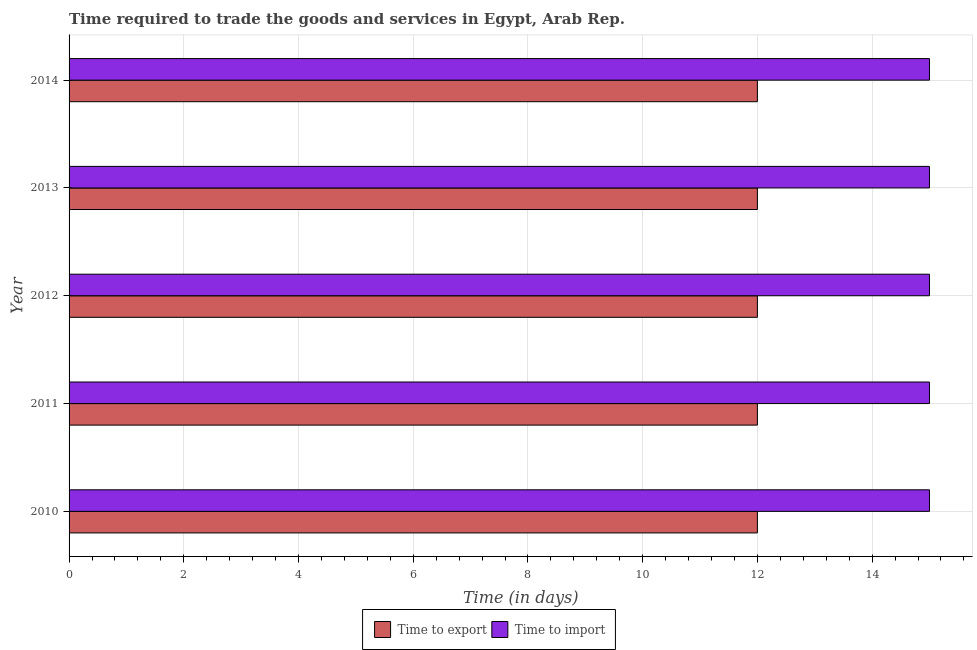Are the number of bars on each tick of the Y-axis equal?
Give a very brief answer. Yes. What is the label of the 3rd group of bars from the top?
Provide a succinct answer. 2012. What is the time to import in 2011?
Your answer should be very brief. 15. Across all years, what is the maximum time to export?
Provide a short and direct response. 12. Across all years, what is the minimum time to import?
Your response must be concise. 15. In which year was the time to import maximum?
Your response must be concise. 2010. In which year was the time to import minimum?
Make the answer very short. 2010. What is the total time to import in the graph?
Provide a short and direct response. 75. What is the difference between the time to export in 2010 and the time to import in 2013?
Keep it short and to the point. -3. In the year 2014, what is the difference between the time to import and time to export?
Provide a succinct answer. 3. In how many years, is the time to import greater than 8.4 days?
Your response must be concise. 5. What is the ratio of the time to export in 2011 to that in 2012?
Your answer should be compact. 1. Is the time to import in 2012 less than that in 2013?
Make the answer very short. No. What is the difference between the highest and the second highest time to import?
Ensure brevity in your answer.  0. Is the sum of the time to export in 2011 and 2014 greater than the maximum time to import across all years?
Your response must be concise. Yes. What does the 2nd bar from the top in 2011 represents?
Ensure brevity in your answer.  Time to export. What does the 2nd bar from the bottom in 2012 represents?
Keep it short and to the point. Time to import. How many bars are there?
Ensure brevity in your answer.  10. How many years are there in the graph?
Your answer should be very brief. 5. Are the values on the major ticks of X-axis written in scientific E-notation?
Ensure brevity in your answer.  No. How are the legend labels stacked?
Give a very brief answer. Horizontal. What is the title of the graph?
Your response must be concise. Time required to trade the goods and services in Egypt, Arab Rep. Does "Arms imports" appear as one of the legend labels in the graph?
Keep it short and to the point. No. What is the label or title of the X-axis?
Your answer should be very brief. Time (in days). What is the Time (in days) of Time to import in 2010?
Your answer should be compact. 15. What is the Time (in days) of Time to import in 2012?
Keep it short and to the point. 15. What is the Time (in days) in Time to import in 2014?
Your answer should be compact. 15. Across all years, what is the maximum Time (in days) in Time to export?
Your answer should be very brief. 12. Across all years, what is the maximum Time (in days) in Time to import?
Offer a very short reply. 15. Across all years, what is the minimum Time (in days) of Time to export?
Offer a terse response. 12. Across all years, what is the minimum Time (in days) of Time to import?
Ensure brevity in your answer.  15. What is the total Time (in days) of Time to export in the graph?
Your response must be concise. 60. What is the total Time (in days) in Time to import in the graph?
Your answer should be compact. 75. What is the difference between the Time (in days) in Time to export in 2010 and that in 2011?
Your response must be concise. 0. What is the difference between the Time (in days) in Time to export in 2010 and that in 2012?
Give a very brief answer. 0. What is the difference between the Time (in days) of Time to import in 2010 and that in 2012?
Ensure brevity in your answer.  0. What is the difference between the Time (in days) of Time to export in 2010 and that in 2013?
Provide a short and direct response. 0. What is the difference between the Time (in days) in Time to import in 2010 and that in 2014?
Keep it short and to the point. 0. What is the difference between the Time (in days) in Time to export in 2011 and that in 2013?
Provide a succinct answer. 0. What is the difference between the Time (in days) in Time to import in 2011 and that in 2013?
Ensure brevity in your answer.  0. What is the difference between the Time (in days) of Time to export in 2011 and that in 2014?
Keep it short and to the point. 0. What is the difference between the Time (in days) in Time to export in 2012 and that in 2013?
Offer a very short reply. 0. What is the difference between the Time (in days) of Time to export in 2012 and that in 2014?
Make the answer very short. 0. What is the difference between the Time (in days) of Time to import in 2012 and that in 2014?
Your response must be concise. 0. What is the difference between the Time (in days) in Time to export in 2013 and that in 2014?
Make the answer very short. 0. What is the difference between the Time (in days) in Time to export in 2010 and the Time (in days) in Time to import in 2011?
Keep it short and to the point. -3. What is the difference between the Time (in days) of Time to export in 2010 and the Time (in days) of Time to import in 2013?
Provide a succinct answer. -3. What is the difference between the Time (in days) of Time to export in 2011 and the Time (in days) of Time to import in 2012?
Make the answer very short. -3. What is the difference between the Time (in days) of Time to export in 2011 and the Time (in days) of Time to import in 2014?
Give a very brief answer. -3. What is the difference between the Time (in days) in Time to export in 2012 and the Time (in days) in Time to import in 2013?
Keep it short and to the point. -3. What is the average Time (in days) of Time to import per year?
Your answer should be very brief. 15. In the year 2012, what is the difference between the Time (in days) in Time to export and Time (in days) in Time to import?
Offer a terse response. -3. What is the ratio of the Time (in days) in Time to import in 2010 to that in 2012?
Your answer should be very brief. 1. What is the ratio of the Time (in days) of Time to export in 2011 to that in 2012?
Your answer should be compact. 1. What is the ratio of the Time (in days) in Time to import in 2011 to that in 2014?
Your response must be concise. 1. What is the ratio of the Time (in days) in Time to import in 2012 to that in 2013?
Ensure brevity in your answer.  1. What is the ratio of the Time (in days) in Time to export in 2012 to that in 2014?
Give a very brief answer. 1. What is the ratio of the Time (in days) in Time to import in 2012 to that in 2014?
Offer a very short reply. 1. What is the ratio of the Time (in days) of Time to export in 2013 to that in 2014?
Make the answer very short. 1. What is the ratio of the Time (in days) of Time to import in 2013 to that in 2014?
Offer a terse response. 1. What is the difference between the highest and the second highest Time (in days) in Time to export?
Offer a terse response. 0. What is the difference between the highest and the second highest Time (in days) of Time to import?
Your answer should be compact. 0. What is the difference between the highest and the lowest Time (in days) of Time to export?
Your answer should be very brief. 0. What is the difference between the highest and the lowest Time (in days) of Time to import?
Offer a terse response. 0. 